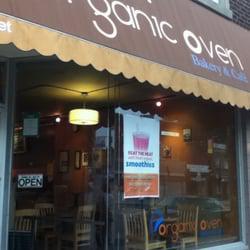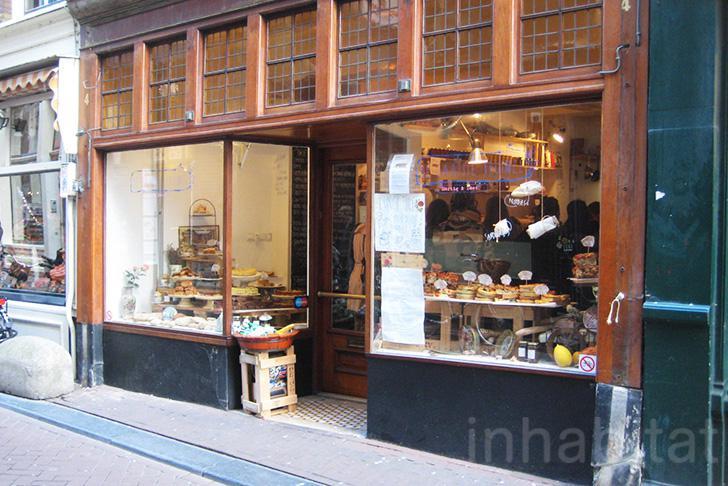The first image is the image on the left, the second image is the image on the right. Given the left and right images, does the statement "One of the store fronts has a brown awning." hold true? Answer yes or no. Yes. The first image is the image on the left, the second image is the image on the right. Assess this claim about the two images: "Front doors are visible in both images.". Correct or not? Answer yes or no. No. 